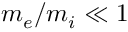Convert formula to latex. <formula><loc_0><loc_0><loc_500><loc_500>m _ { e } / m _ { i } \ll 1</formula> 